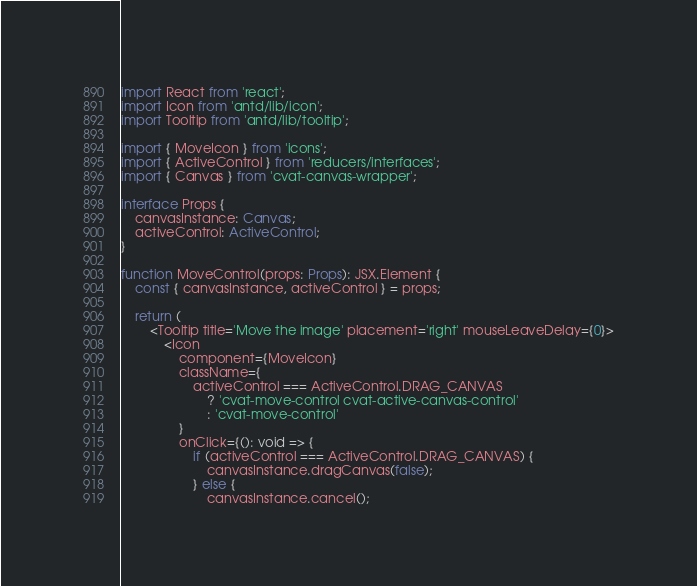Convert code to text. <code><loc_0><loc_0><loc_500><loc_500><_TypeScript_>import React from 'react';
import Icon from 'antd/lib/icon';
import Tooltip from 'antd/lib/tooltip';

import { MoveIcon } from 'icons';
import { ActiveControl } from 'reducers/interfaces';
import { Canvas } from 'cvat-canvas-wrapper';

interface Props {
    canvasInstance: Canvas;
    activeControl: ActiveControl;
}

function MoveControl(props: Props): JSX.Element {
    const { canvasInstance, activeControl } = props;

    return (
        <Tooltip title='Move the image' placement='right' mouseLeaveDelay={0}>
            <Icon
                component={MoveIcon}
                className={
                    activeControl === ActiveControl.DRAG_CANVAS
                        ? 'cvat-move-control cvat-active-canvas-control'
                        : 'cvat-move-control'
                }
                onClick={(): void => {
                    if (activeControl === ActiveControl.DRAG_CANVAS) {
                        canvasInstance.dragCanvas(false);
                    } else {
                        canvasInstance.cancel();</code> 